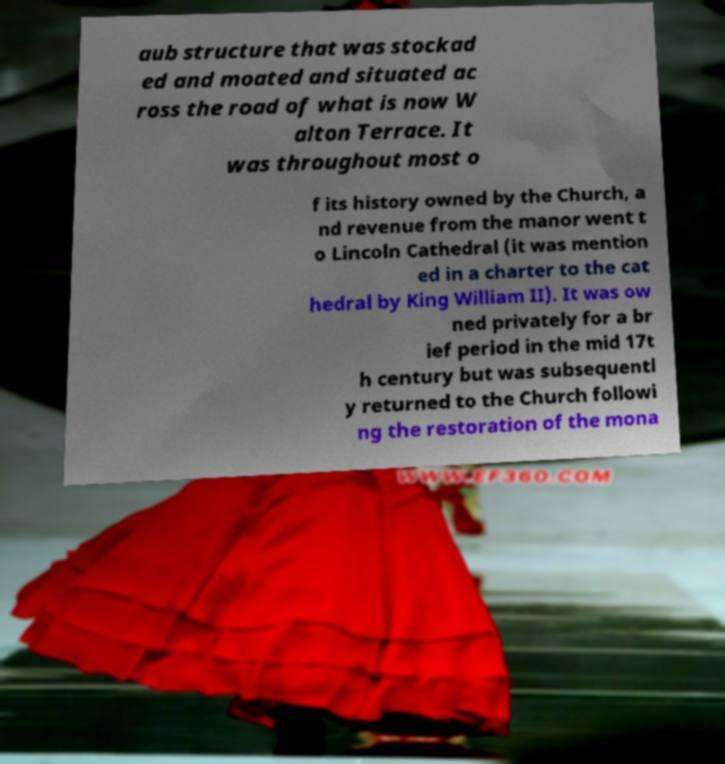Can you read and provide the text displayed in the image?This photo seems to have some interesting text. Can you extract and type it out for me? aub structure that was stockad ed and moated and situated ac ross the road of what is now W alton Terrace. It was throughout most o f its history owned by the Church, a nd revenue from the manor went t o Lincoln Cathedral (it was mention ed in a charter to the cat hedral by King William II). It was ow ned privately for a br ief period in the mid 17t h century but was subsequentl y returned to the Church followi ng the restoration of the mona 